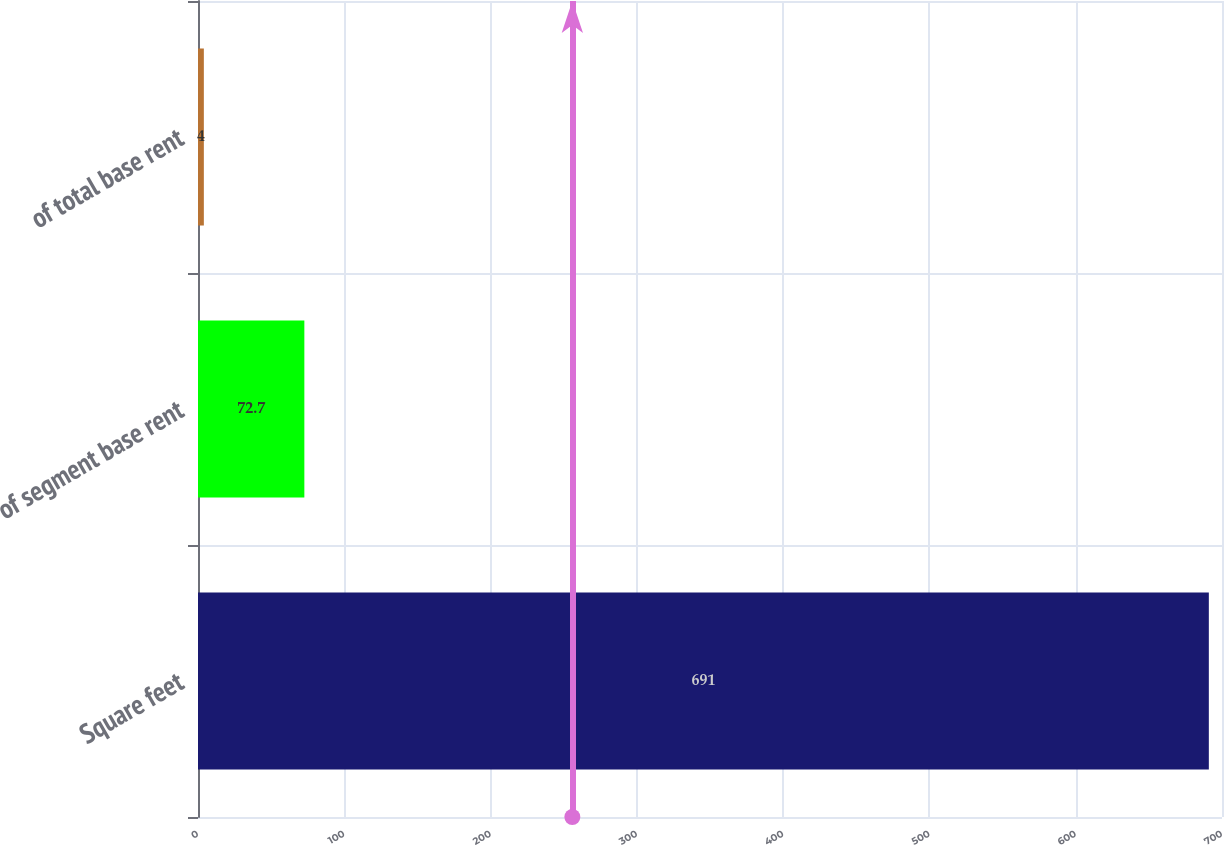Convert chart to OTSL. <chart><loc_0><loc_0><loc_500><loc_500><bar_chart><fcel>Square feet<fcel>of segment base rent<fcel>of total base rent<nl><fcel>691<fcel>72.7<fcel>4<nl></chart> 